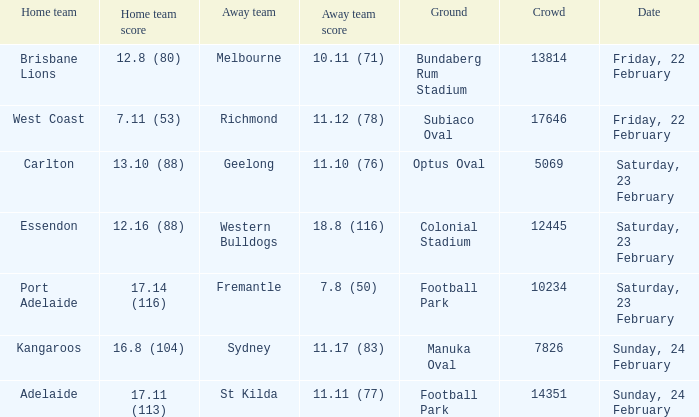On what date did the away team Fremantle play? Saturday, 23 February. 